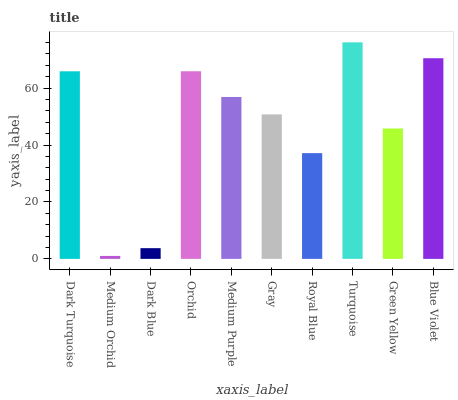Is Medium Orchid the minimum?
Answer yes or no. Yes. Is Turquoise the maximum?
Answer yes or no. Yes. Is Dark Blue the minimum?
Answer yes or no. No. Is Dark Blue the maximum?
Answer yes or no. No. Is Dark Blue greater than Medium Orchid?
Answer yes or no. Yes. Is Medium Orchid less than Dark Blue?
Answer yes or no. Yes. Is Medium Orchid greater than Dark Blue?
Answer yes or no. No. Is Dark Blue less than Medium Orchid?
Answer yes or no. No. Is Medium Purple the high median?
Answer yes or no. Yes. Is Gray the low median?
Answer yes or no. Yes. Is Green Yellow the high median?
Answer yes or no. No. Is Green Yellow the low median?
Answer yes or no. No. 